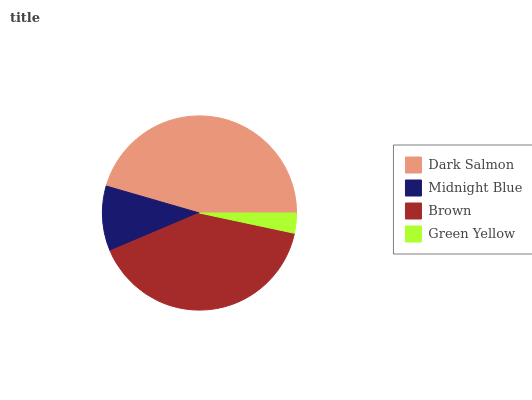Is Green Yellow the minimum?
Answer yes or no. Yes. Is Dark Salmon the maximum?
Answer yes or no. Yes. Is Midnight Blue the minimum?
Answer yes or no. No. Is Midnight Blue the maximum?
Answer yes or no. No. Is Dark Salmon greater than Midnight Blue?
Answer yes or no. Yes. Is Midnight Blue less than Dark Salmon?
Answer yes or no. Yes. Is Midnight Blue greater than Dark Salmon?
Answer yes or no. No. Is Dark Salmon less than Midnight Blue?
Answer yes or no. No. Is Brown the high median?
Answer yes or no. Yes. Is Midnight Blue the low median?
Answer yes or no. Yes. Is Green Yellow the high median?
Answer yes or no. No. Is Brown the low median?
Answer yes or no. No. 